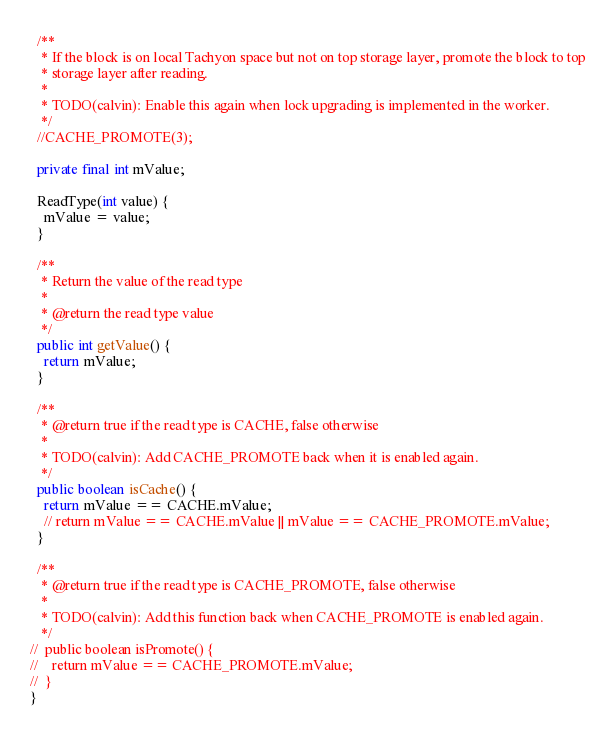Convert code to text. <code><loc_0><loc_0><loc_500><loc_500><_Java_>
  /**
   * If the block is on local Tachyon space but not on top storage layer, promote the block to top
   * storage layer after reading.
   *
   * TODO(calvin): Enable this again when lock upgrading is implemented in the worker.
   */
  //CACHE_PROMOTE(3);

  private final int mValue;

  ReadType(int value) {
    mValue = value;
  }

  /**
   * Return the value of the read type
   *
   * @return the read type value
   */
  public int getValue() {
    return mValue;
  }

  /**
   * @return true if the read type is CACHE, false otherwise
   *
   * TODO(calvin): Add CACHE_PROMOTE back when it is enabled again.
   */
  public boolean isCache() {
    return mValue == CACHE.mValue;
    // return mValue == CACHE.mValue || mValue == CACHE_PROMOTE.mValue;
  }

  /**
   * @return true if the read type is CACHE_PROMOTE, false otherwise
   *
   * TODO(calvin): Add this function back when CACHE_PROMOTE is enabled again.
   */
//  public boolean isPromote() {
//    return mValue == CACHE_PROMOTE.mValue;
//  }
}
</code> 